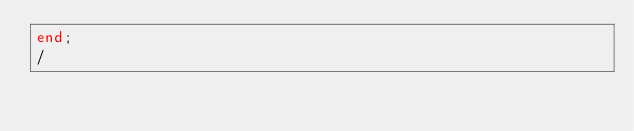<code> <loc_0><loc_0><loc_500><loc_500><_SQL_>end;
/
</code> 